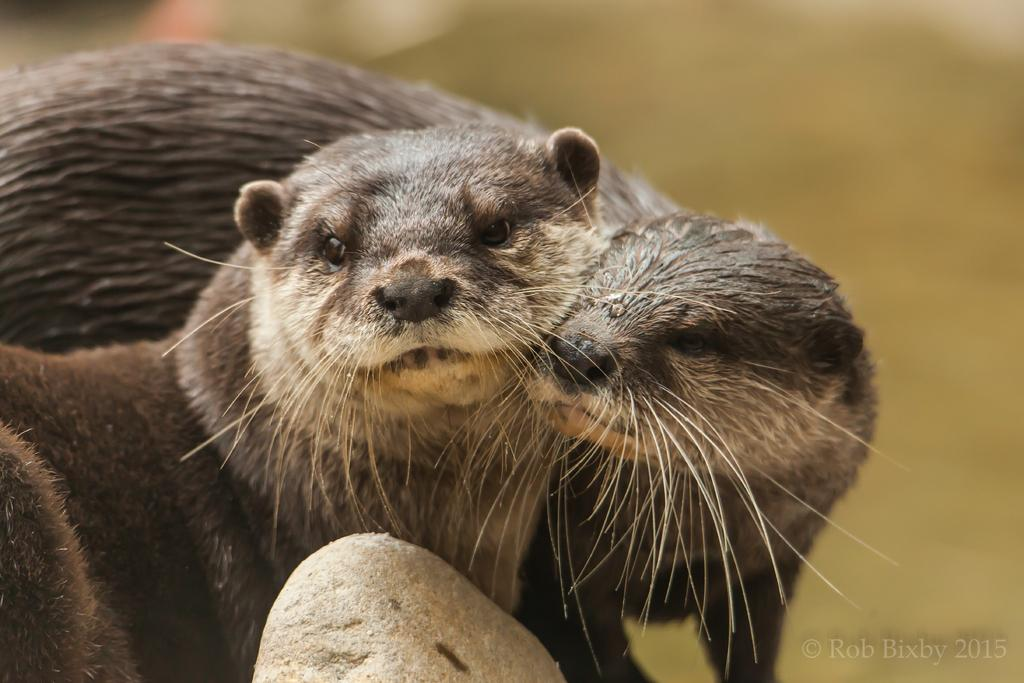What types of living organisms can be seen in the image? There are two animals in the image. How close are the animals to each other? The animals are near each other in the image. What can be seen in the background of the image? The background of the image is clear. What type of button can be seen growing on the roof in the image? There is no button or roof present in the image; it features two animals near each other with a clear background. 